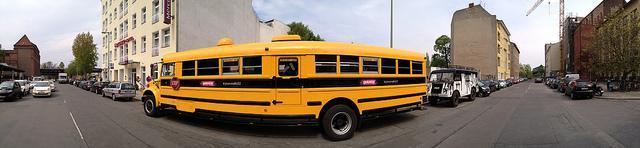How many windows are on the bus?
Give a very brief answer. 12. 